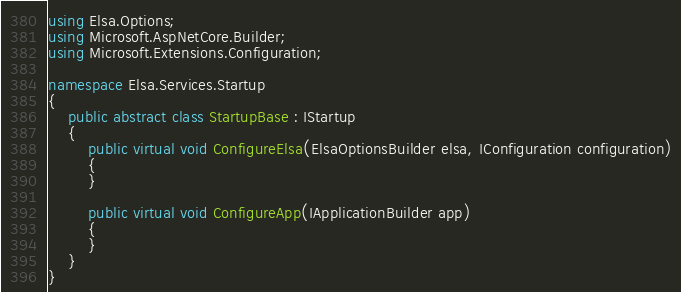<code> <loc_0><loc_0><loc_500><loc_500><_C#_>using Elsa.Options;
using Microsoft.AspNetCore.Builder;
using Microsoft.Extensions.Configuration;

namespace Elsa.Services.Startup
{
    public abstract class StartupBase : IStartup
    {
        public virtual void ConfigureElsa(ElsaOptionsBuilder elsa, IConfiguration configuration)
        {
        }

        public virtual void ConfigureApp(IApplicationBuilder app)
        {
        }
    }
}</code> 